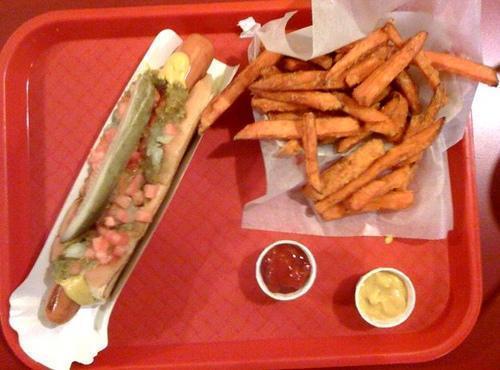What is on the left of the tray?
Answer the question by selecting the correct answer among the 4 following choices and explain your choice with a short sentence. The answer should be formatted with the following format: `Answer: choice
Rationale: rationale.`
Options: Fish, hot dog, hamburger, bagel. Answer: hot dog.
Rationale: It is long bread and meat with toppings 